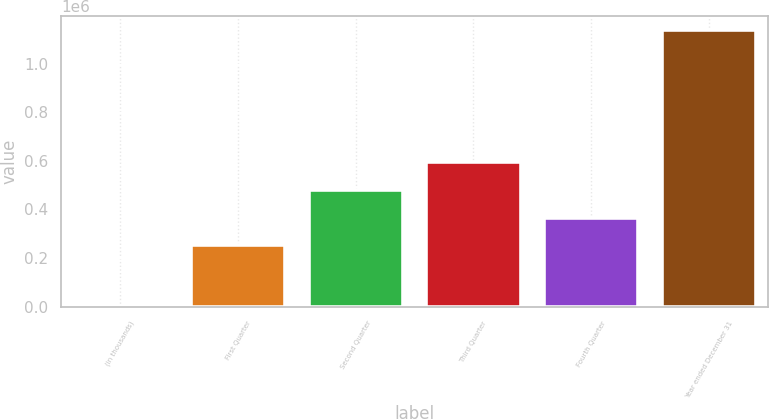Convert chart. <chart><loc_0><loc_0><loc_500><loc_500><bar_chart><fcel>(in thousands)<fcel>First Quarter<fcel>Second Quarter<fcel>Third Quarter<fcel>Fourth Quarter<fcel>Year ended December 31<nl><fcel>2010<fcel>253041<fcel>480017<fcel>593505<fcel>366529<fcel>1.13689e+06<nl></chart> 